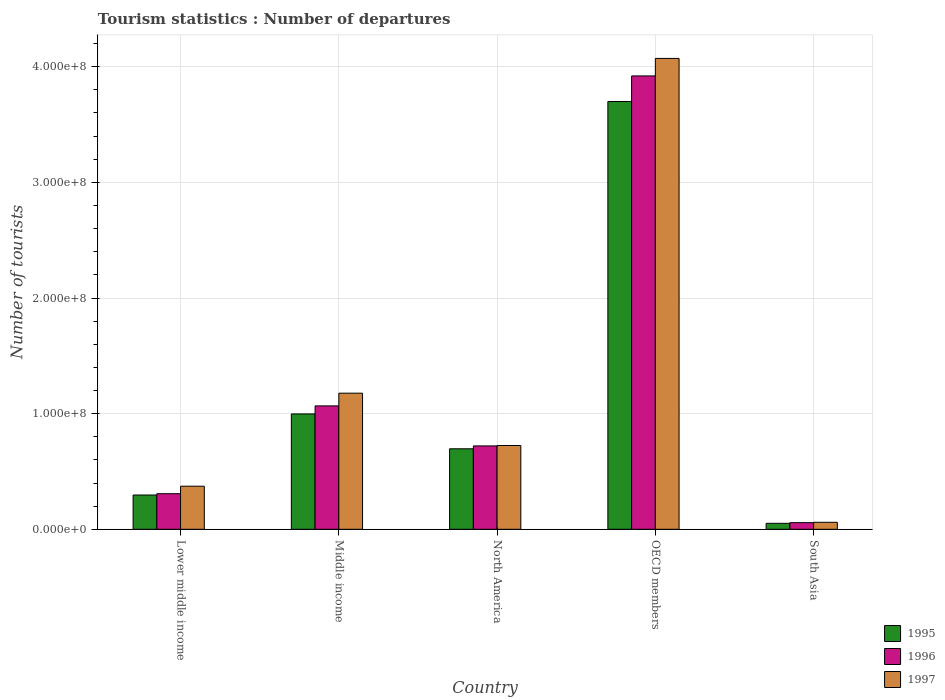Are the number of bars per tick equal to the number of legend labels?
Give a very brief answer. Yes. How many bars are there on the 1st tick from the left?
Keep it short and to the point. 3. In how many cases, is the number of bars for a given country not equal to the number of legend labels?
Ensure brevity in your answer.  0. What is the number of tourist departures in 1996 in Middle income?
Make the answer very short. 1.07e+08. Across all countries, what is the maximum number of tourist departures in 1997?
Keep it short and to the point. 4.07e+08. Across all countries, what is the minimum number of tourist departures in 1995?
Offer a very short reply. 5.17e+06. In which country was the number of tourist departures in 1997 maximum?
Your answer should be compact. OECD members. What is the total number of tourist departures in 1995 in the graph?
Provide a succinct answer. 5.74e+08. What is the difference between the number of tourist departures in 1996 in OECD members and that in South Asia?
Offer a very short reply. 3.86e+08. What is the difference between the number of tourist departures in 1997 in OECD members and the number of tourist departures in 1996 in Lower middle income?
Offer a terse response. 3.76e+08. What is the average number of tourist departures in 1995 per country?
Provide a succinct answer. 1.15e+08. What is the difference between the number of tourist departures of/in 1996 and number of tourist departures of/in 1995 in Lower middle income?
Offer a terse response. 1.14e+06. In how many countries, is the number of tourist departures in 1995 greater than 320000000?
Give a very brief answer. 1. What is the ratio of the number of tourist departures in 1995 in North America to that in South Asia?
Offer a very short reply. 13.47. What is the difference between the highest and the second highest number of tourist departures in 1996?
Offer a very short reply. 2.85e+08. What is the difference between the highest and the lowest number of tourist departures in 1995?
Offer a terse response. 3.65e+08. In how many countries, is the number of tourist departures in 1995 greater than the average number of tourist departures in 1995 taken over all countries?
Your response must be concise. 1. Is the sum of the number of tourist departures in 1997 in Middle income and South Asia greater than the maximum number of tourist departures in 1996 across all countries?
Provide a short and direct response. No. How many bars are there?
Provide a succinct answer. 15. Are all the bars in the graph horizontal?
Offer a terse response. No. How many countries are there in the graph?
Ensure brevity in your answer.  5. What is the difference between two consecutive major ticks on the Y-axis?
Your answer should be very brief. 1.00e+08. Are the values on the major ticks of Y-axis written in scientific E-notation?
Ensure brevity in your answer.  Yes. Does the graph contain any zero values?
Offer a terse response. No. How many legend labels are there?
Keep it short and to the point. 3. How are the legend labels stacked?
Your answer should be very brief. Vertical. What is the title of the graph?
Your answer should be compact. Tourism statistics : Number of departures. What is the label or title of the Y-axis?
Offer a very short reply. Number of tourists. What is the Number of tourists in 1995 in Lower middle income?
Provide a succinct answer. 2.96e+07. What is the Number of tourists in 1996 in Lower middle income?
Give a very brief answer. 3.08e+07. What is the Number of tourists of 1997 in Lower middle income?
Offer a terse response. 3.73e+07. What is the Number of tourists in 1995 in Middle income?
Offer a terse response. 9.98e+07. What is the Number of tourists of 1996 in Middle income?
Provide a succinct answer. 1.07e+08. What is the Number of tourists in 1997 in Middle income?
Your response must be concise. 1.18e+08. What is the Number of tourists of 1995 in North America?
Offer a terse response. 6.96e+07. What is the Number of tourists of 1996 in North America?
Make the answer very short. 7.21e+07. What is the Number of tourists in 1997 in North America?
Offer a very short reply. 7.25e+07. What is the Number of tourists of 1995 in OECD members?
Offer a very short reply. 3.70e+08. What is the Number of tourists in 1996 in OECD members?
Provide a succinct answer. 3.92e+08. What is the Number of tourists in 1997 in OECD members?
Your response must be concise. 4.07e+08. What is the Number of tourists of 1995 in South Asia?
Provide a short and direct response. 5.17e+06. What is the Number of tourists in 1996 in South Asia?
Your response must be concise. 5.74e+06. What is the Number of tourists in 1997 in South Asia?
Give a very brief answer. 6.04e+06. Across all countries, what is the maximum Number of tourists in 1995?
Offer a very short reply. 3.70e+08. Across all countries, what is the maximum Number of tourists of 1996?
Your answer should be compact. 3.92e+08. Across all countries, what is the maximum Number of tourists of 1997?
Ensure brevity in your answer.  4.07e+08. Across all countries, what is the minimum Number of tourists of 1995?
Ensure brevity in your answer.  5.17e+06. Across all countries, what is the minimum Number of tourists of 1996?
Your response must be concise. 5.74e+06. Across all countries, what is the minimum Number of tourists in 1997?
Offer a very short reply. 6.04e+06. What is the total Number of tourists of 1995 in the graph?
Offer a terse response. 5.74e+08. What is the total Number of tourists of 1996 in the graph?
Your answer should be compact. 6.07e+08. What is the total Number of tourists in 1997 in the graph?
Offer a terse response. 6.41e+08. What is the difference between the Number of tourists of 1995 in Lower middle income and that in Middle income?
Your answer should be very brief. -7.01e+07. What is the difference between the Number of tourists in 1996 in Lower middle income and that in Middle income?
Your answer should be compact. -7.59e+07. What is the difference between the Number of tourists in 1997 in Lower middle income and that in Middle income?
Your response must be concise. -8.04e+07. What is the difference between the Number of tourists of 1995 in Lower middle income and that in North America?
Offer a terse response. -4.00e+07. What is the difference between the Number of tourists in 1996 in Lower middle income and that in North America?
Offer a very short reply. -4.13e+07. What is the difference between the Number of tourists in 1997 in Lower middle income and that in North America?
Give a very brief answer. -3.52e+07. What is the difference between the Number of tourists of 1995 in Lower middle income and that in OECD members?
Your answer should be very brief. -3.40e+08. What is the difference between the Number of tourists in 1996 in Lower middle income and that in OECD members?
Your answer should be very brief. -3.61e+08. What is the difference between the Number of tourists of 1997 in Lower middle income and that in OECD members?
Keep it short and to the point. -3.70e+08. What is the difference between the Number of tourists of 1995 in Lower middle income and that in South Asia?
Offer a terse response. 2.45e+07. What is the difference between the Number of tourists of 1996 in Lower middle income and that in South Asia?
Offer a terse response. 2.50e+07. What is the difference between the Number of tourists in 1997 in Lower middle income and that in South Asia?
Ensure brevity in your answer.  3.12e+07. What is the difference between the Number of tourists of 1995 in Middle income and that in North America?
Provide a succinct answer. 3.02e+07. What is the difference between the Number of tourists of 1996 in Middle income and that in North America?
Make the answer very short. 3.46e+07. What is the difference between the Number of tourists in 1997 in Middle income and that in North America?
Provide a short and direct response. 4.52e+07. What is the difference between the Number of tourists of 1995 in Middle income and that in OECD members?
Make the answer very short. -2.70e+08. What is the difference between the Number of tourists of 1996 in Middle income and that in OECD members?
Give a very brief answer. -2.85e+08. What is the difference between the Number of tourists of 1997 in Middle income and that in OECD members?
Keep it short and to the point. -2.89e+08. What is the difference between the Number of tourists in 1995 in Middle income and that in South Asia?
Provide a short and direct response. 9.46e+07. What is the difference between the Number of tourists of 1996 in Middle income and that in South Asia?
Provide a short and direct response. 1.01e+08. What is the difference between the Number of tourists in 1997 in Middle income and that in South Asia?
Ensure brevity in your answer.  1.12e+08. What is the difference between the Number of tourists of 1995 in North America and that in OECD members?
Make the answer very short. -3.00e+08. What is the difference between the Number of tourists in 1996 in North America and that in OECD members?
Keep it short and to the point. -3.20e+08. What is the difference between the Number of tourists of 1997 in North America and that in OECD members?
Ensure brevity in your answer.  -3.35e+08. What is the difference between the Number of tourists in 1995 in North America and that in South Asia?
Keep it short and to the point. 6.44e+07. What is the difference between the Number of tourists in 1996 in North America and that in South Asia?
Ensure brevity in your answer.  6.64e+07. What is the difference between the Number of tourists of 1997 in North America and that in South Asia?
Offer a very short reply. 6.64e+07. What is the difference between the Number of tourists of 1995 in OECD members and that in South Asia?
Make the answer very short. 3.65e+08. What is the difference between the Number of tourists of 1996 in OECD members and that in South Asia?
Offer a terse response. 3.86e+08. What is the difference between the Number of tourists of 1997 in OECD members and that in South Asia?
Make the answer very short. 4.01e+08. What is the difference between the Number of tourists in 1995 in Lower middle income and the Number of tourists in 1996 in Middle income?
Make the answer very short. -7.71e+07. What is the difference between the Number of tourists in 1995 in Lower middle income and the Number of tourists in 1997 in Middle income?
Provide a short and direct response. -8.81e+07. What is the difference between the Number of tourists in 1996 in Lower middle income and the Number of tourists in 1997 in Middle income?
Offer a terse response. -8.69e+07. What is the difference between the Number of tourists of 1995 in Lower middle income and the Number of tourists of 1996 in North America?
Your answer should be very brief. -4.25e+07. What is the difference between the Number of tourists of 1995 in Lower middle income and the Number of tourists of 1997 in North America?
Make the answer very short. -4.28e+07. What is the difference between the Number of tourists in 1996 in Lower middle income and the Number of tourists in 1997 in North America?
Your answer should be compact. -4.17e+07. What is the difference between the Number of tourists of 1995 in Lower middle income and the Number of tourists of 1996 in OECD members?
Ensure brevity in your answer.  -3.62e+08. What is the difference between the Number of tourists of 1995 in Lower middle income and the Number of tourists of 1997 in OECD members?
Your answer should be very brief. -3.78e+08. What is the difference between the Number of tourists of 1996 in Lower middle income and the Number of tourists of 1997 in OECD members?
Offer a very short reply. -3.76e+08. What is the difference between the Number of tourists in 1995 in Lower middle income and the Number of tourists in 1996 in South Asia?
Your answer should be compact. 2.39e+07. What is the difference between the Number of tourists of 1995 in Lower middle income and the Number of tourists of 1997 in South Asia?
Your answer should be very brief. 2.36e+07. What is the difference between the Number of tourists in 1996 in Lower middle income and the Number of tourists in 1997 in South Asia?
Make the answer very short. 2.47e+07. What is the difference between the Number of tourists of 1995 in Middle income and the Number of tourists of 1996 in North America?
Ensure brevity in your answer.  2.77e+07. What is the difference between the Number of tourists of 1995 in Middle income and the Number of tourists of 1997 in North America?
Ensure brevity in your answer.  2.73e+07. What is the difference between the Number of tourists of 1996 in Middle income and the Number of tourists of 1997 in North America?
Give a very brief answer. 3.42e+07. What is the difference between the Number of tourists of 1995 in Middle income and the Number of tourists of 1996 in OECD members?
Ensure brevity in your answer.  -2.92e+08. What is the difference between the Number of tourists of 1995 in Middle income and the Number of tourists of 1997 in OECD members?
Give a very brief answer. -3.07e+08. What is the difference between the Number of tourists of 1996 in Middle income and the Number of tourists of 1997 in OECD members?
Make the answer very short. -3.00e+08. What is the difference between the Number of tourists in 1995 in Middle income and the Number of tourists in 1996 in South Asia?
Your response must be concise. 9.40e+07. What is the difference between the Number of tourists in 1995 in Middle income and the Number of tourists in 1997 in South Asia?
Offer a terse response. 9.37e+07. What is the difference between the Number of tourists in 1996 in Middle income and the Number of tourists in 1997 in South Asia?
Keep it short and to the point. 1.01e+08. What is the difference between the Number of tourists in 1995 in North America and the Number of tourists in 1996 in OECD members?
Offer a terse response. -3.22e+08. What is the difference between the Number of tourists of 1995 in North America and the Number of tourists of 1997 in OECD members?
Your answer should be very brief. -3.38e+08. What is the difference between the Number of tourists in 1996 in North America and the Number of tourists in 1997 in OECD members?
Keep it short and to the point. -3.35e+08. What is the difference between the Number of tourists of 1995 in North America and the Number of tourists of 1996 in South Asia?
Your response must be concise. 6.39e+07. What is the difference between the Number of tourists in 1995 in North America and the Number of tourists in 1997 in South Asia?
Make the answer very short. 6.36e+07. What is the difference between the Number of tourists of 1996 in North America and the Number of tourists of 1997 in South Asia?
Give a very brief answer. 6.61e+07. What is the difference between the Number of tourists in 1995 in OECD members and the Number of tourists in 1996 in South Asia?
Your answer should be compact. 3.64e+08. What is the difference between the Number of tourists in 1995 in OECD members and the Number of tourists in 1997 in South Asia?
Provide a succinct answer. 3.64e+08. What is the difference between the Number of tourists of 1996 in OECD members and the Number of tourists of 1997 in South Asia?
Your answer should be compact. 3.86e+08. What is the average Number of tourists in 1995 per country?
Provide a succinct answer. 1.15e+08. What is the average Number of tourists of 1996 per country?
Your answer should be very brief. 1.21e+08. What is the average Number of tourists of 1997 per country?
Make the answer very short. 1.28e+08. What is the difference between the Number of tourists in 1995 and Number of tourists in 1996 in Lower middle income?
Give a very brief answer. -1.14e+06. What is the difference between the Number of tourists of 1995 and Number of tourists of 1997 in Lower middle income?
Offer a terse response. -7.61e+06. What is the difference between the Number of tourists of 1996 and Number of tourists of 1997 in Lower middle income?
Provide a succinct answer. -6.47e+06. What is the difference between the Number of tourists of 1995 and Number of tourists of 1996 in Middle income?
Provide a succinct answer. -6.94e+06. What is the difference between the Number of tourists of 1995 and Number of tourists of 1997 in Middle income?
Make the answer very short. -1.79e+07. What is the difference between the Number of tourists in 1996 and Number of tourists in 1997 in Middle income?
Make the answer very short. -1.10e+07. What is the difference between the Number of tourists of 1995 and Number of tourists of 1996 in North America?
Your answer should be very brief. -2.49e+06. What is the difference between the Number of tourists of 1995 and Number of tourists of 1997 in North America?
Your response must be concise. -2.85e+06. What is the difference between the Number of tourists of 1996 and Number of tourists of 1997 in North America?
Offer a terse response. -3.69e+05. What is the difference between the Number of tourists in 1995 and Number of tourists in 1996 in OECD members?
Keep it short and to the point. -2.21e+07. What is the difference between the Number of tourists of 1995 and Number of tourists of 1997 in OECD members?
Ensure brevity in your answer.  -3.72e+07. What is the difference between the Number of tourists in 1996 and Number of tourists in 1997 in OECD members?
Your answer should be very brief. -1.51e+07. What is the difference between the Number of tourists of 1995 and Number of tourists of 1996 in South Asia?
Provide a short and direct response. -5.69e+05. What is the difference between the Number of tourists in 1995 and Number of tourists in 1997 in South Asia?
Offer a terse response. -8.75e+05. What is the difference between the Number of tourists in 1996 and Number of tourists in 1997 in South Asia?
Your response must be concise. -3.06e+05. What is the ratio of the Number of tourists in 1995 in Lower middle income to that in Middle income?
Your answer should be very brief. 0.3. What is the ratio of the Number of tourists of 1996 in Lower middle income to that in Middle income?
Provide a succinct answer. 0.29. What is the ratio of the Number of tourists of 1997 in Lower middle income to that in Middle income?
Offer a very short reply. 0.32. What is the ratio of the Number of tourists of 1995 in Lower middle income to that in North America?
Provide a succinct answer. 0.43. What is the ratio of the Number of tourists of 1996 in Lower middle income to that in North America?
Ensure brevity in your answer.  0.43. What is the ratio of the Number of tourists of 1997 in Lower middle income to that in North America?
Give a very brief answer. 0.51. What is the ratio of the Number of tourists in 1995 in Lower middle income to that in OECD members?
Your response must be concise. 0.08. What is the ratio of the Number of tourists of 1996 in Lower middle income to that in OECD members?
Make the answer very short. 0.08. What is the ratio of the Number of tourists of 1997 in Lower middle income to that in OECD members?
Give a very brief answer. 0.09. What is the ratio of the Number of tourists in 1995 in Lower middle income to that in South Asia?
Make the answer very short. 5.74. What is the ratio of the Number of tourists in 1996 in Lower middle income to that in South Asia?
Provide a short and direct response. 5.37. What is the ratio of the Number of tourists of 1997 in Lower middle income to that in South Asia?
Offer a terse response. 6.17. What is the ratio of the Number of tourists in 1995 in Middle income to that in North America?
Offer a very short reply. 1.43. What is the ratio of the Number of tourists in 1996 in Middle income to that in North America?
Offer a very short reply. 1.48. What is the ratio of the Number of tourists in 1997 in Middle income to that in North America?
Provide a short and direct response. 1.62. What is the ratio of the Number of tourists in 1995 in Middle income to that in OECD members?
Give a very brief answer. 0.27. What is the ratio of the Number of tourists of 1996 in Middle income to that in OECD members?
Provide a short and direct response. 0.27. What is the ratio of the Number of tourists in 1997 in Middle income to that in OECD members?
Offer a terse response. 0.29. What is the ratio of the Number of tourists of 1995 in Middle income to that in South Asia?
Keep it short and to the point. 19.31. What is the ratio of the Number of tourists in 1996 in Middle income to that in South Asia?
Your response must be concise. 18.61. What is the ratio of the Number of tourists in 1997 in Middle income to that in South Asia?
Provide a succinct answer. 19.48. What is the ratio of the Number of tourists in 1995 in North America to that in OECD members?
Provide a short and direct response. 0.19. What is the ratio of the Number of tourists in 1996 in North America to that in OECD members?
Provide a succinct answer. 0.18. What is the ratio of the Number of tourists of 1997 in North America to that in OECD members?
Your answer should be very brief. 0.18. What is the ratio of the Number of tourists of 1995 in North America to that in South Asia?
Provide a succinct answer. 13.47. What is the ratio of the Number of tourists of 1996 in North America to that in South Asia?
Ensure brevity in your answer.  12.57. What is the ratio of the Number of tourists in 1997 in North America to that in South Asia?
Your response must be concise. 12. What is the ratio of the Number of tourists of 1995 in OECD members to that in South Asia?
Ensure brevity in your answer.  71.61. What is the ratio of the Number of tourists in 1996 in OECD members to that in South Asia?
Your answer should be compact. 68.36. What is the ratio of the Number of tourists in 1997 in OECD members to that in South Asia?
Give a very brief answer. 67.4. What is the difference between the highest and the second highest Number of tourists of 1995?
Your answer should be very brief. 2.70e+08. What is the difference between the highest and the second highest Number of tourists in 1996?
Make the answer very short. 2.85e+08. What is the difference between the highest and the second highest Number of tourists of 1997?
Your answer should be compact. 2.89e+08. What is the difference between the highest and the lowest Number of tourists of 1995?
Make the answer very short. 3.65e+08. What is the difference between the highest and the lowest Number of tourists of 1996?
Provide a succinct answer. 3.86e+08. What is the difference between the highest and the lowest Number of tourists of 1997?
Provide a succinct answer. 4.01e+08. 